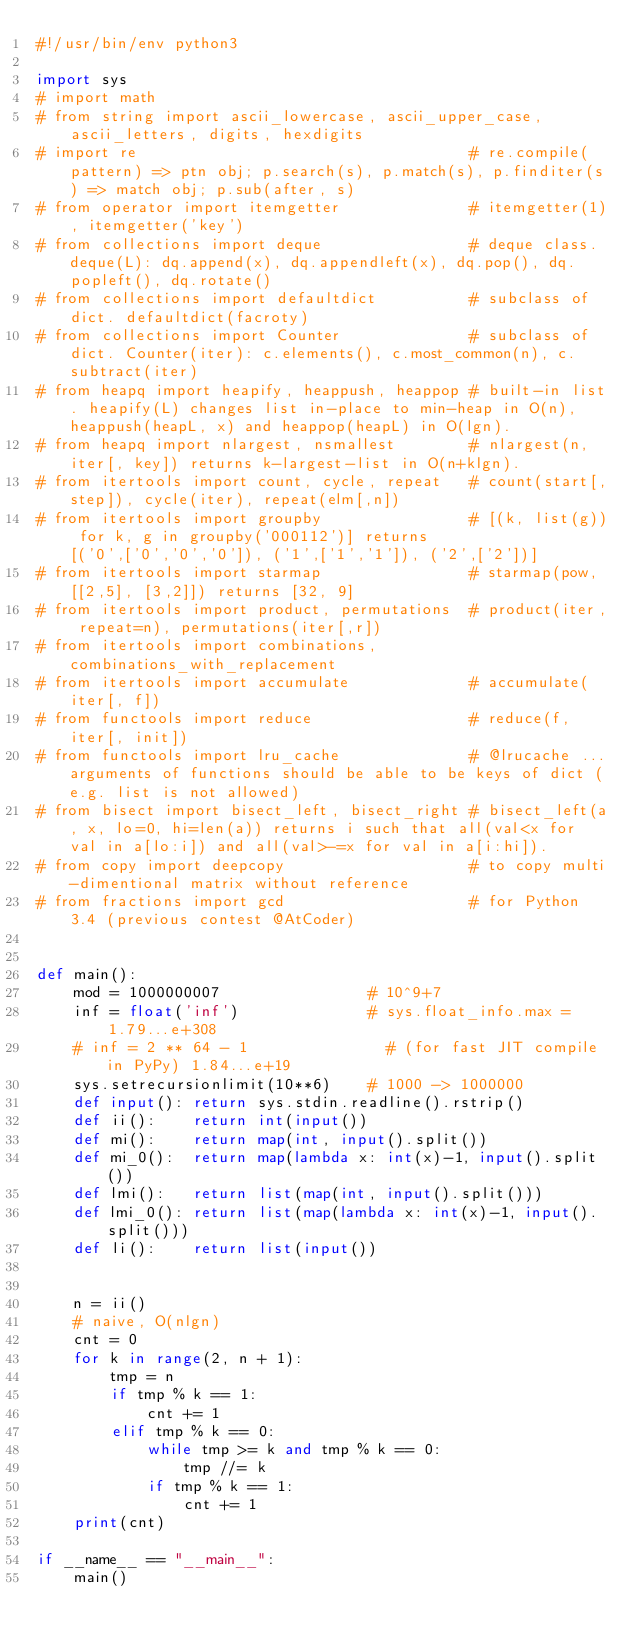<code> <loc_0><loc_0><loc_500><loc_500><_Python_>#!/usr/bin/env python3

import sys
# import math
# from string import ascii_lowercase, ascii_upper_case, ascii_letters, digits, hexdigits
# import re                                    # re.compile(pattern) => ptn obj; p.search(s), p.match(s), p.finditer(s) => match obj; p.sub(after, s)
# from operator import itemgetter              # itemgetter(1), itemgetter('key')
# from collections import deque                # deque class. deque(L): dq.append(x), dq.appendleft(x), dq.pop(), dq.popleft(), dq.rotate()
# from collections import defaultdict          # subclass of dict. defaultdict(facroty)
# from collections import Counter              # subclass of dict. Counter(iter): c.elements(), c.most_common(n), c.subtract(iter)
# from heapq import heapify, heappush, heappop # built-in list. heapify(L) changes list in-place to min-heap in O(n), heappush(heapL, x) and heappop(heapL) in O(lgn).
# from heapq import nlargest, nsmallest        # nlargest(n, iter[, key]) returns k-largest-list in O(n+klgn).
# from itertools import count, cycle, repeat   # count(start[,step]), cycle(iter), repeat(elm[,n])
# from itertools import groupby                # [(k, list(g)) for k, g in groupby('000112')] returns [('0',['0','0','0']), ('1',['1','1']), ('2',['2'])]
# from itertools import starmap                # starmap(pow, [[2,5], [3,2]]) returns [32, 9]
# from itertools import product, permutations  # product(iter, repeat=n), permutations(iter[,r])
# from itertools import combinations, combinations_with_replacement
# from itertools import accumulate             # accumulate(iter[, f])
# from functools import reduce                 # reduce(f, iter[, init])
# from functools import lru_cache              # @lrucache ...arguments of functions should be able to be keys of dict (e.g. list is not allowed)
# from bisect import bisect_left, bisect_right # bisect_left(a, x, lo=0, hi=len(a)) returns i such that all(val<x for val in a[lo:i]) and all(val>-=x for val in a[i:hi]).
# from copy import deepcopy                    # to copy multi-dimentional matrix without reference
# from fractions import gcd                    # for Python 3.4 (previous contest @AtCoder)


def main():
    mod = 1000000007                # 10^9+7
    inf = float('inf')              # sys.float_info.max = 1.79...e+308
    # inf = 2 ** 64 - 1               # (for fast JIT compile in PyPy) 1.84...e+19
    sys.setrecursionlimit(10**6)    # 1000 -> 1000000
    def input(): return sys.stdin.readline().rstrip()
    def ii():    return int(input())
    def mi():    return map(int, input().split())
    def mi_0():  return map(lambda x: int(x)-1, input().split())
    def lmi():   return list(map(int, input().split()))
    def lmi_0(): return list(map(lambda x: int(x)-1, input().split()))
    def li():    return list(input())
    
    
    n = ii()
    # naive, O(nlgn)
    cnt = 0
    for k in range(2, n + 1):
        tmp = n
        if tmp % k == 1:
            cnt += 1
        elif tmp % k == 0:
            while tmp >= k and tmp % k == 0:
                tmp //= k
            if tmp % k == 1:
                cnt += 1
    print(cnt)

if __name__ == "__main__":
    main()
</code> 